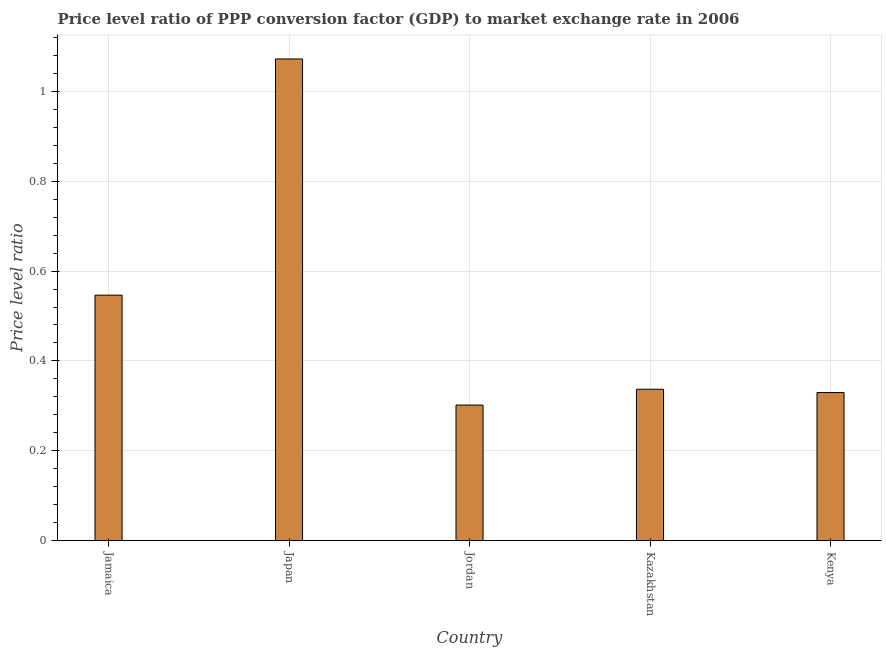Does the graph contain any zero values?
Provide a short and direct response. No. Does the graph contain grids?
Give a very brief answer. Yes. What is the title of the graph?
Your answer should be compact. Price level ratio of PPP conversion factor (GDP) to market exchange rate in 2006. What is the label or title of the Y-axis?
Your answer should be compact. Price level ratio. What is the price level ratio in Kazakhstan?
Ensure brevity in your answer.  0.34. Across all countries, what is the maximum price level ratio?
Offer a very short reply. 1.07. Across all countries, what is the minimum price level ratio?
Provide a succinct answer. 0.3. In which country was the price level ratio maximum?
Provide a succinct answer. Japan. In which country was the price level ratio minimum?
Your answer should be compact. Jordan. What is the sum of the price level ratio?
Provide a short and direct response. 2.59. What is the difference between the price level ratio in Jamaica and Jordan?
Ensure brevity in your answer.  0.24. What is the average price level ratio per country?
Offer a terse response. 0.52. What is the median price level ratio?
Provide a succinct answer. 0.34. In how many countries, is the price level ratio greater than 0.8 ?
Provide a short and direct response. 1. What is the ratio of the price level ratio in Jordan to that in Kenya?
Your response must be concise. 0.92. What is the difference between the highest and the second highest price level ratio?
Keep it short and to the point. 0.53. Is the sum of the price level ratio in Jamaica and Kenya greater than the maximum price level ratio across all countries?
Keep it short and to the point. No. What is the difference between the highest and the lowest price level ratio?
Ensure brevity in your answer.  0.77. What is the difference between two consecutive major ticks on the Y-axis?
Your answer should be very brief. 0.2. What is the Price level ratio in Jamaica?
Keep it short and to the point. 0.55. What is the Price level ratio of Japan?
Keep it short and to the point. 1.07. What is the Price level ratio of Jordan?
Your answer should be very brief. 0.3. What is the Price level ratio in Kazakhstan?
Offer a very short reply. 0.34. What is the Price level ratio in Kenya?
Your response must be concise. 0.33. What is the difference between the Price level ratio in Jamaica and Japan?
Offer a very short reply. -0.53. What is the difference between the Price level ratio in Jamaica and Jordan?
Offer a very short reply. 0.24. What is the difference between the Price level ratio in Jamaica and Kazakhstan?
Your response must be concise. 0.21. What is the difference between the Price level ratio in Jamaica and Kenya?
Offer a terse response. 0.22. What is the difference between the Price level ratio in Japan and Jordan?
Offer a very short reply. 0.77. What is the difference between the Price level ratio in Japan and Kazakhstan?
Make the answer very short. 0.73. What is the difference between the Price level ratio in Japan and Kenya?
Keep it short and to the point. 0.74. What is the difference between the Price level ratio in Jordan and Kazakhstan?
Make the answer very short. -0.04. What is the difference between the Price level ratio in Jordan and Kenya?
Provide a short and direct response. -0.03. What is the difference between the Price level ratio in Kazakhstan and Kenya?
Give a very brief answer. 0.01. What is the ratio of the Price level ratio in Jamaica to that in Japan?
Offer a terse response. 0.51. What is the ratio of the Price level ratio in Jamaica to that in Jordan?
Your response must be concise. 1.81. What is the ratio of the Price level ratio in Jamaica to that in Kazakhstan?
Give a very brief answer. 1.62. What is the ratio of the Price level ratio in Jamaica to that in Kenya?
Your answer should be very brief. 1.66. What is the ratio of the Price level ratio in Japan to that in Jordan?
Give a very brief answer. 3.55. What is the ratio of the Price level ratio in Japan to that in Kazakhstan?
Ensure brevity in your answer.  3.18. What is the ratio of the Price level ratio in Japan to that in Kenya?
Your response must be concise. 3.25. What is the ratio of the Price level ratio in Jordan to that in Kazakhstan?
Your answer should be compact. 0.9. What is the ratio of the Price level ratio in Jordan to that in Kenya?
Give a very brief answer. 0.92. What is the ratio of the Price level ratio in Kazakhstan to that in Kenya?
Provide a short and direct response. 1.02. 